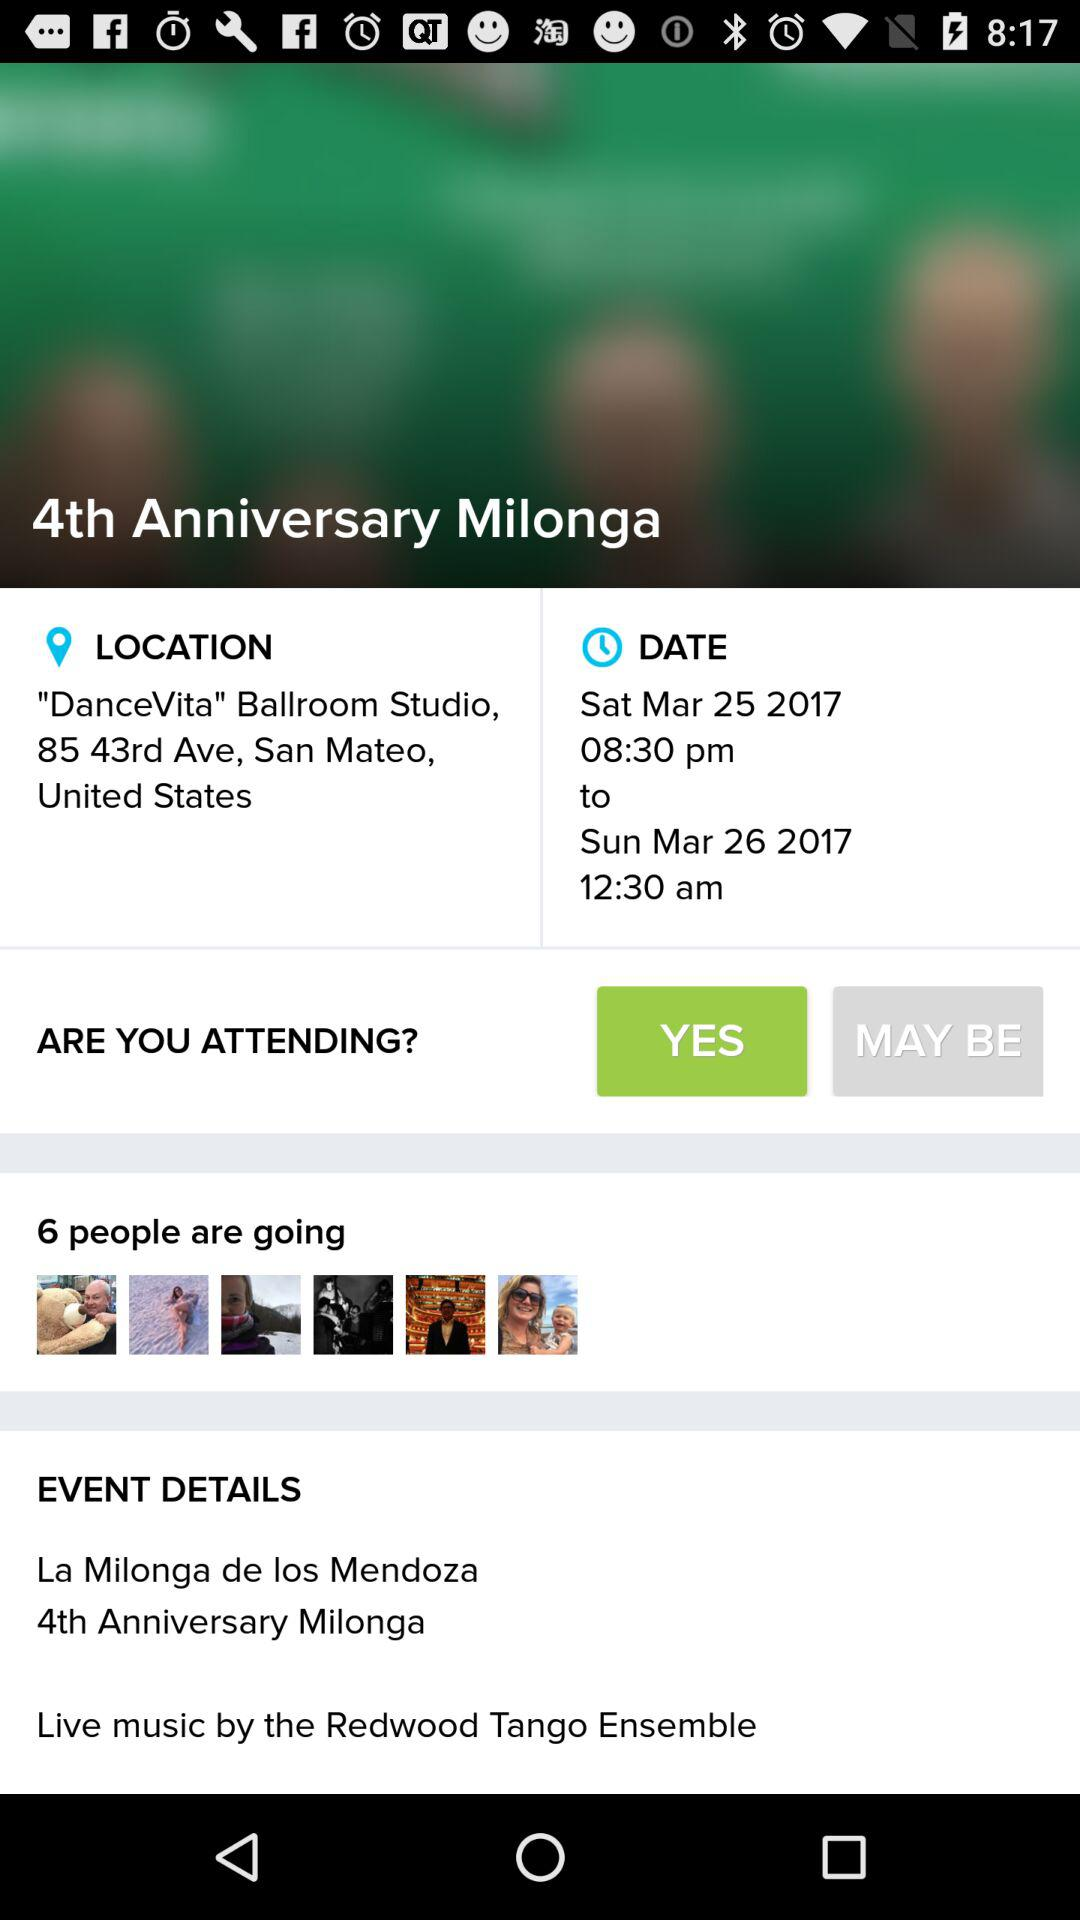What is the location? The location is Clubhouse at Rancho Solano, 3250 Rancho Solano Pkwy, Fairfield, United States. 